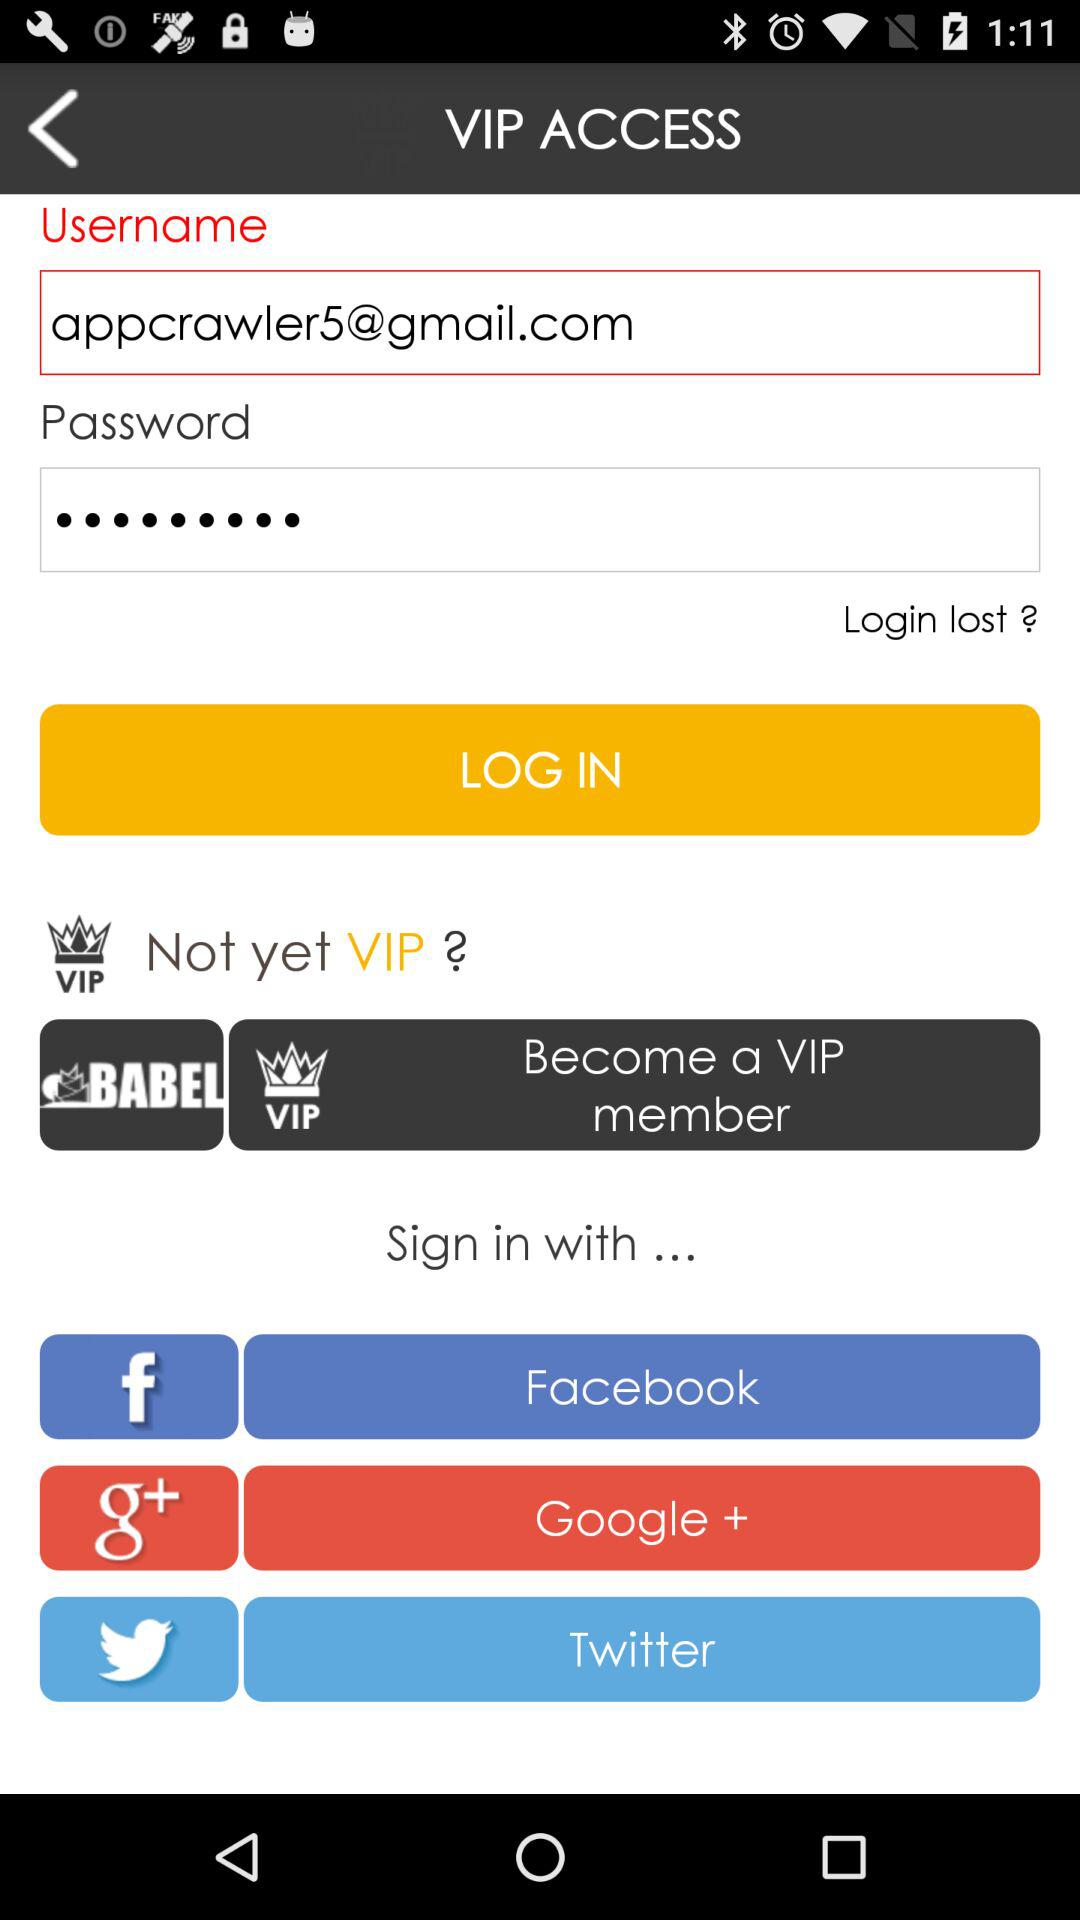What's the Gmail address used in place of the username? The used Gmail address is appcrawler5@gmail.com. 